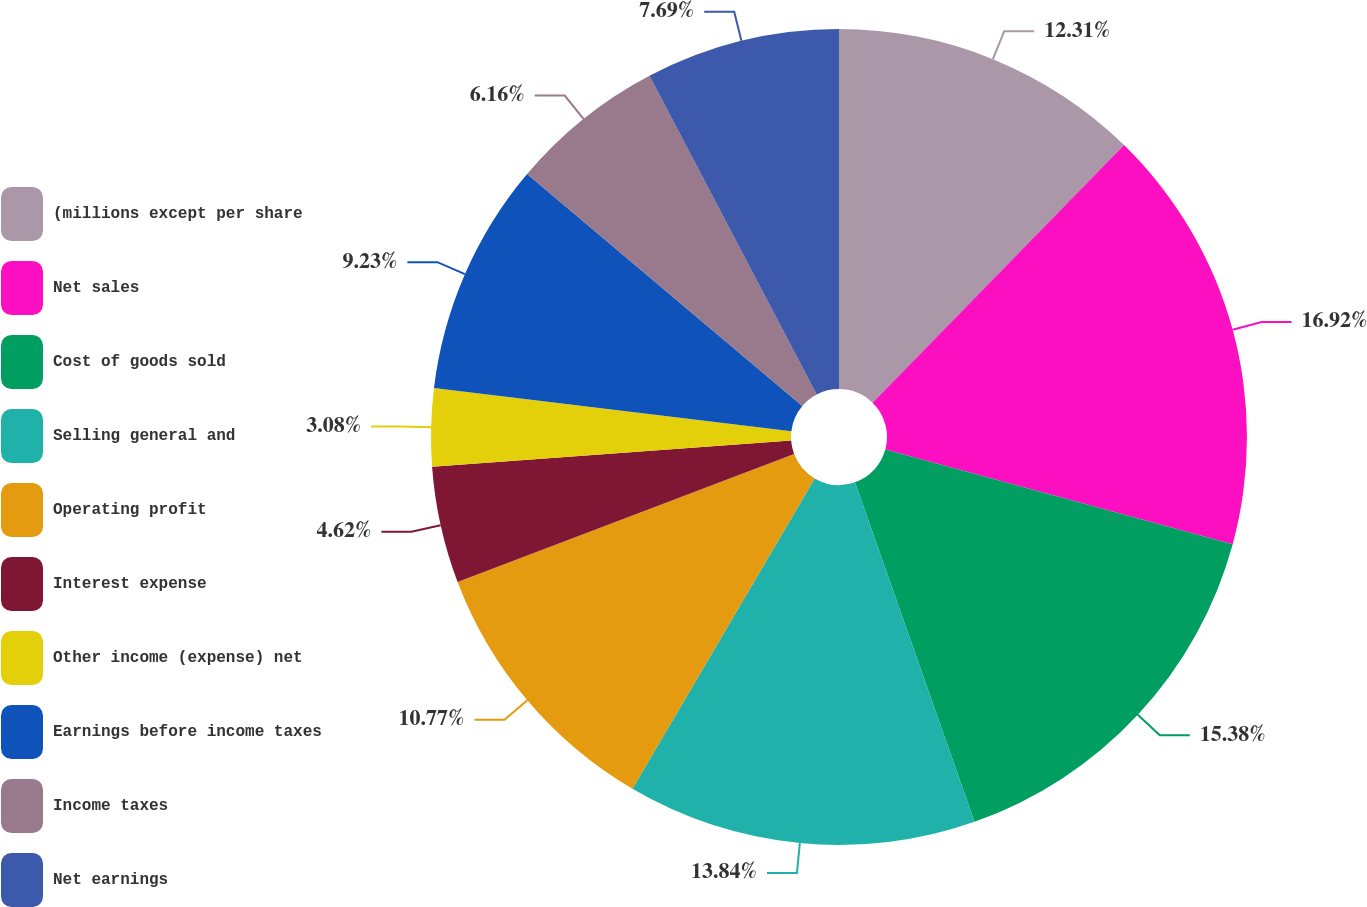Convert chart to OTSL. <chart><loc_0><loc_0><loc_500><loc_500><pie_chart><fcel>(millions except per share<fcel>Net sales<fcel>Cost of goods sold<fcel>Selling general and<fcel>Operating profit<fcel>Interest expense<fcel>Other income (expense) net<fcel>Earnings before income taxes<fcel>Income taxes<fcel>Net earnings<nl><fcel>12.31%<fcel>16.92%<fcel>15.38%<fcel>13.84%<fcel>10.77%<fcel>4.62%<fcel>3.08%<fcel>9.23%<fcel>6.16%<fcel>7.69%<nl></chart> 